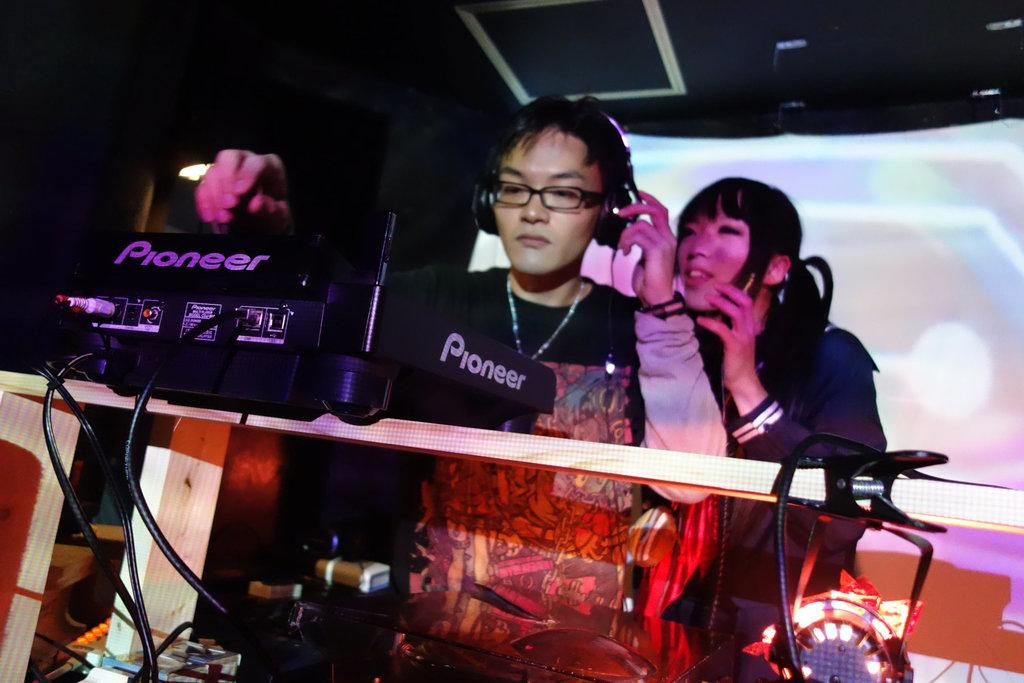What is the main subject of the image? There is a person in the image. What is the person wearing? The person is wearing headphones. What is the person doing in the image? The person is DJ mixing. Can you describe the person's surroundings? There is a girl standing behind the person. How many spiders are crawling on the DJ equipment in the image? There are no spiders visible in the image; the focus is on the person DJ mixing and the girl standing behind them. 